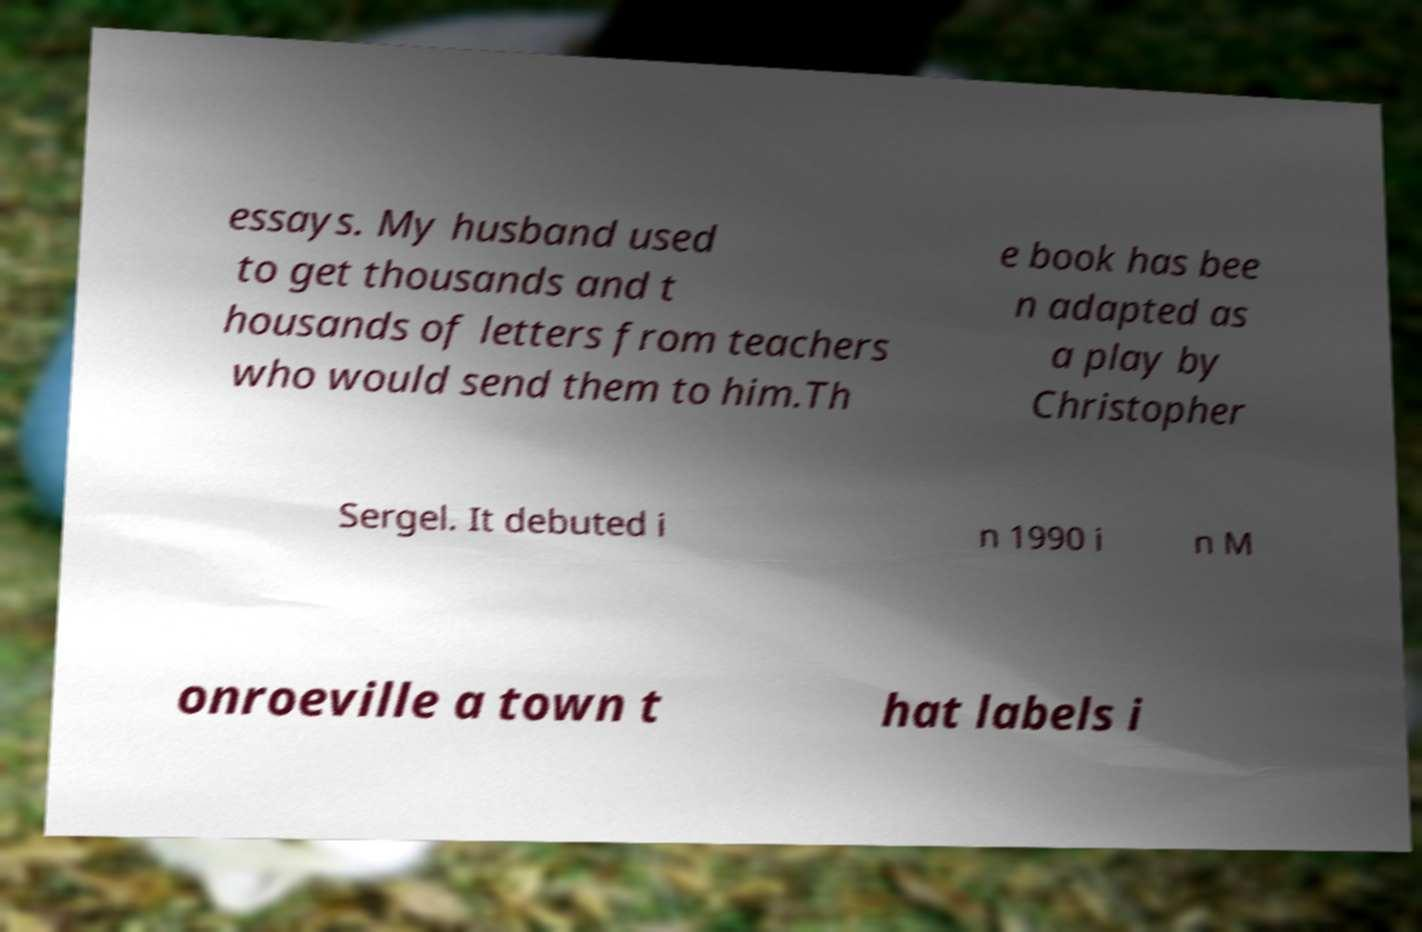Could you assist in decoding the text presented in this image and type it out clearly? essays. My husband used to get thousands and t housands of letters from teachers who would send them to him.Th e book has bee n adapted as a play by Christopher Sergel. It debuted i n 1990 i n M onroeville a town t hat labels i 